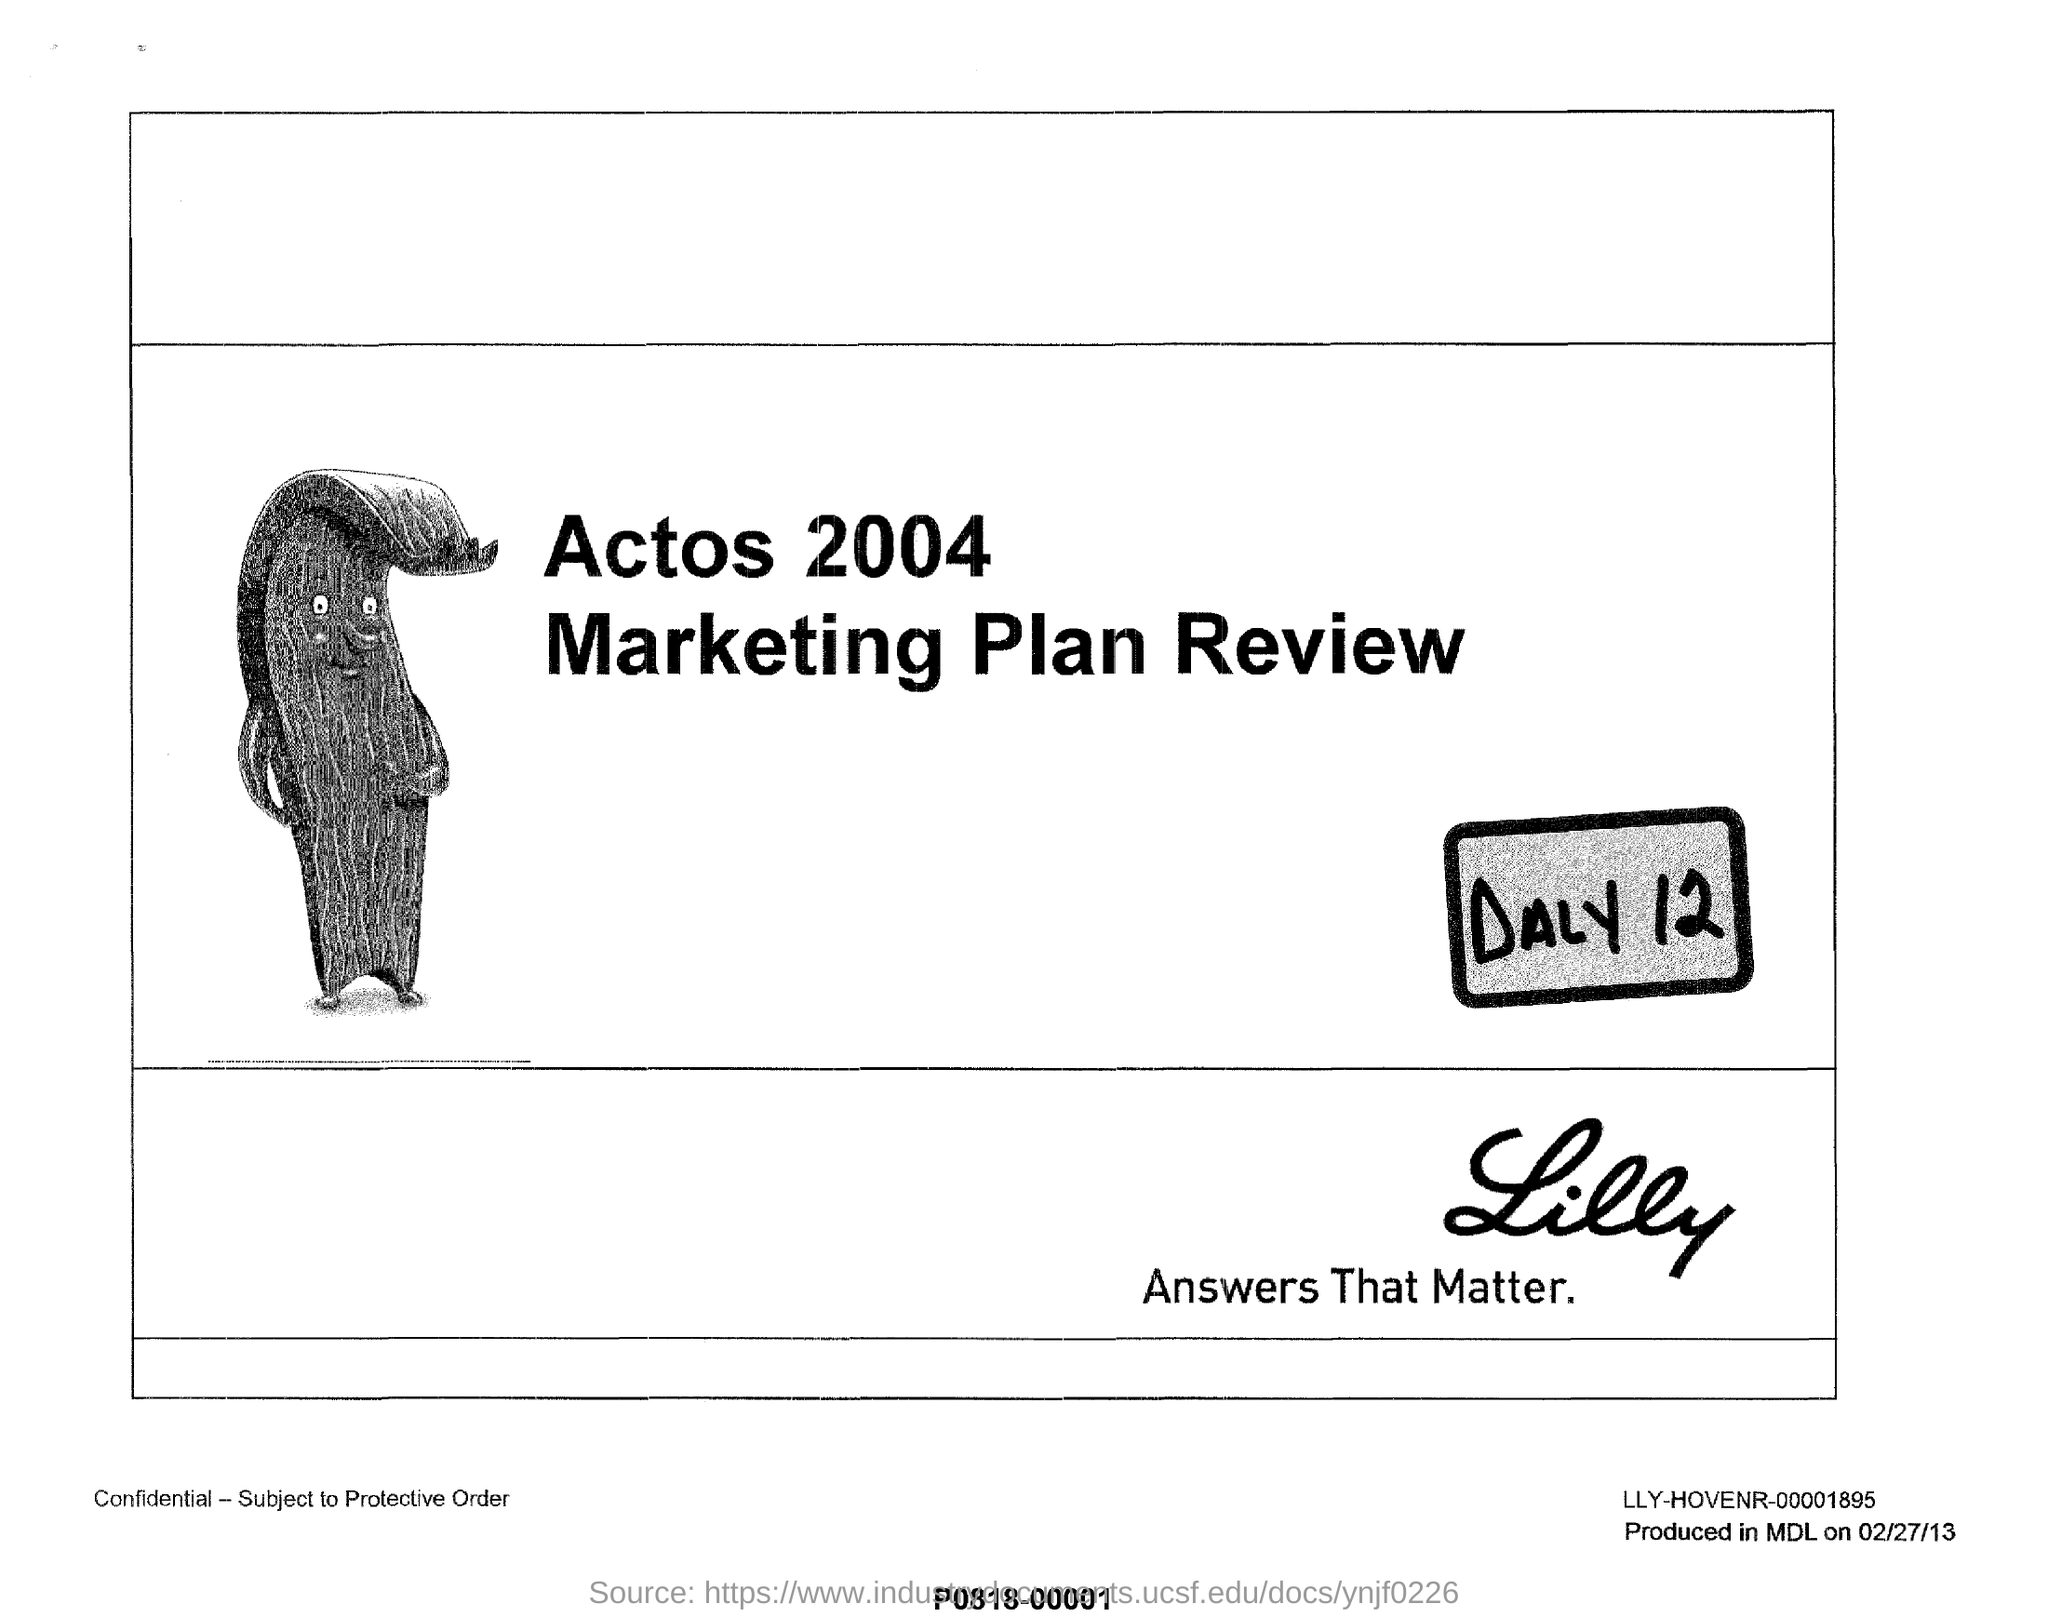Indicate a few pertinent items in this graphic. The year given for Actos is 2004. The name of the plan review is the Marketing Plan Review. 